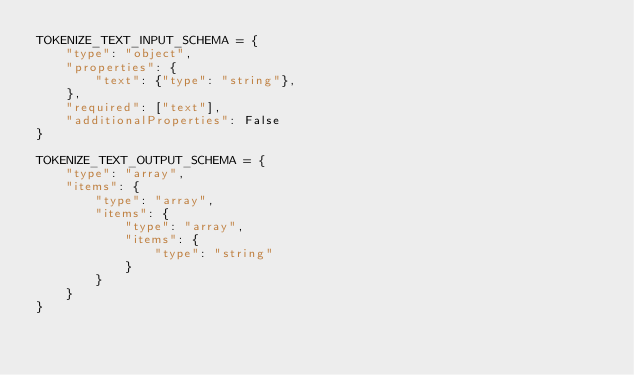Convert code to text. <code><loc_0><loc_0><loc_500><loc_500><_Python_>TOKENIZE_TEXT_INPUT_SCHEMA = {
    "type": "object",
    "properties": {
        "text": {"type": "string"},
    },
    "required": ["text"],
    "additionalProperties": False
}

TOKENIZE_TEXT_OUTPUT_SCHEMA = {
    "type": "array",
    "items": {
        "type": "array",
        "items": {
            "type": "array",
            "items": {
                "type": "string"
            }
        }
    }
}
</code> 